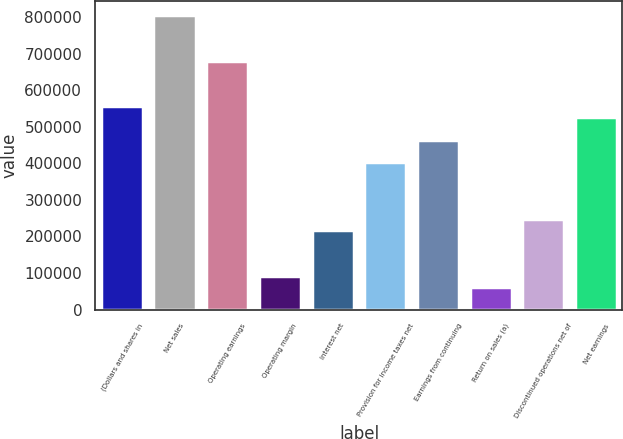Convert chart. <chart><loc_0><loc_0><loc_500><loc_500><bar_chart><fcel>(Dollars and shares in<fcel>Net sales<fcel>Operating earnings<fcel>Operating margin<fcel>Interest net<fcel>Provision for income taxes net<fcel>Earnings from continuing<fcel>Return on sales (a)<fcel>Discontinued operations net of<fcel>Net earnings<nl><fcel>556739<fcel>804179<fcel>680459<fcel>92790.6<fcel>216510<fcel>402090<fcel>463950<fcel>61860.7<fcel>247440<fcel>525809<nl></chart> 